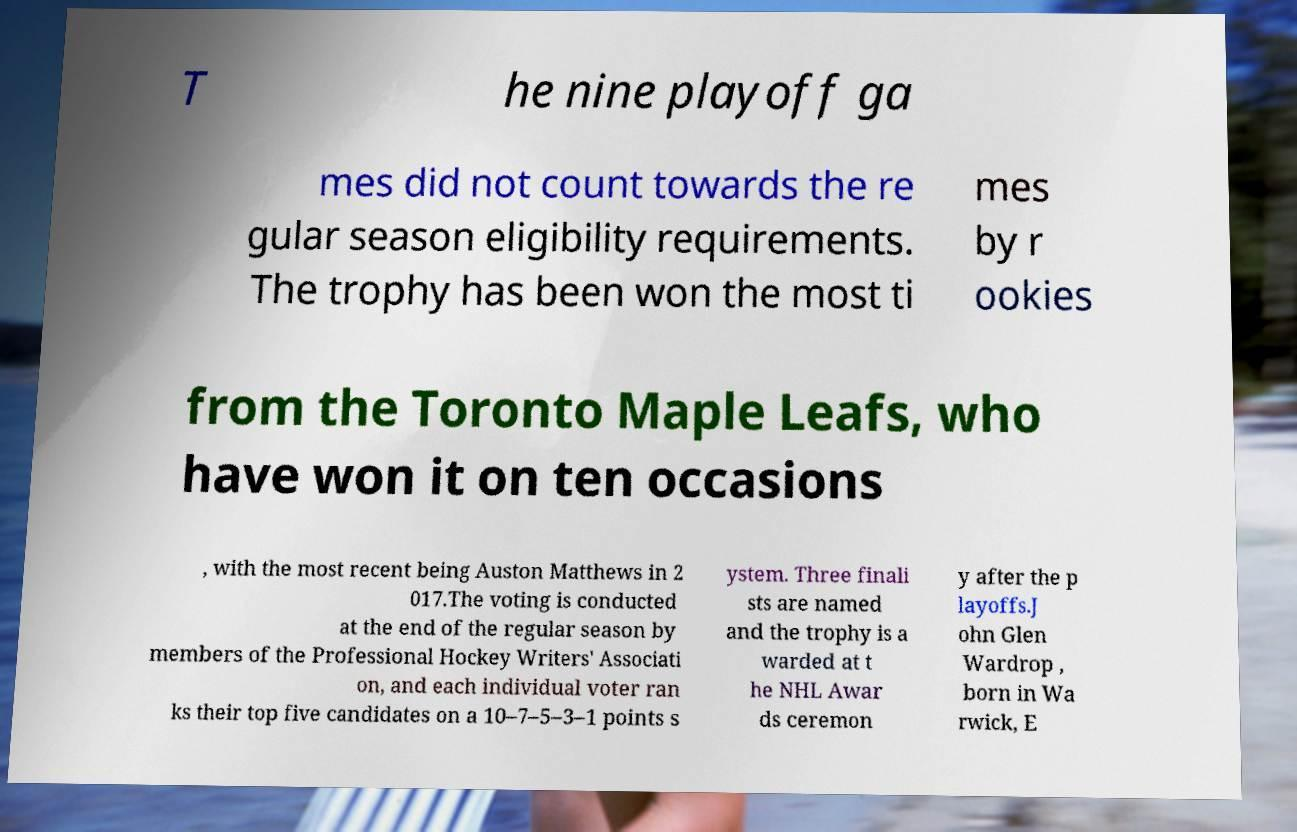What messages or text are displayed in this image? I need them in a readable, typed format. T he nine playoff ga mes did not count towards the re gular season eligibility requirements. The trophy has been won the most ti mes by r ookies from the Toronto Maple Leafs, who have won it on ten occasions , with the most recent being Auston Matthews in 2 017.The voting is conducted at the end of the regular season by members of the Professional Hockey Writers' Associati on, and each individual voter ran ks their top five candidates on a 10–7–5–3–1 points s ystem. Three finali sts are named and the trophy is a warded at t he NHL Awar ds ceremon y after the p layoffs.J ohn Glen Wardrop , born in Wa rwick, E 